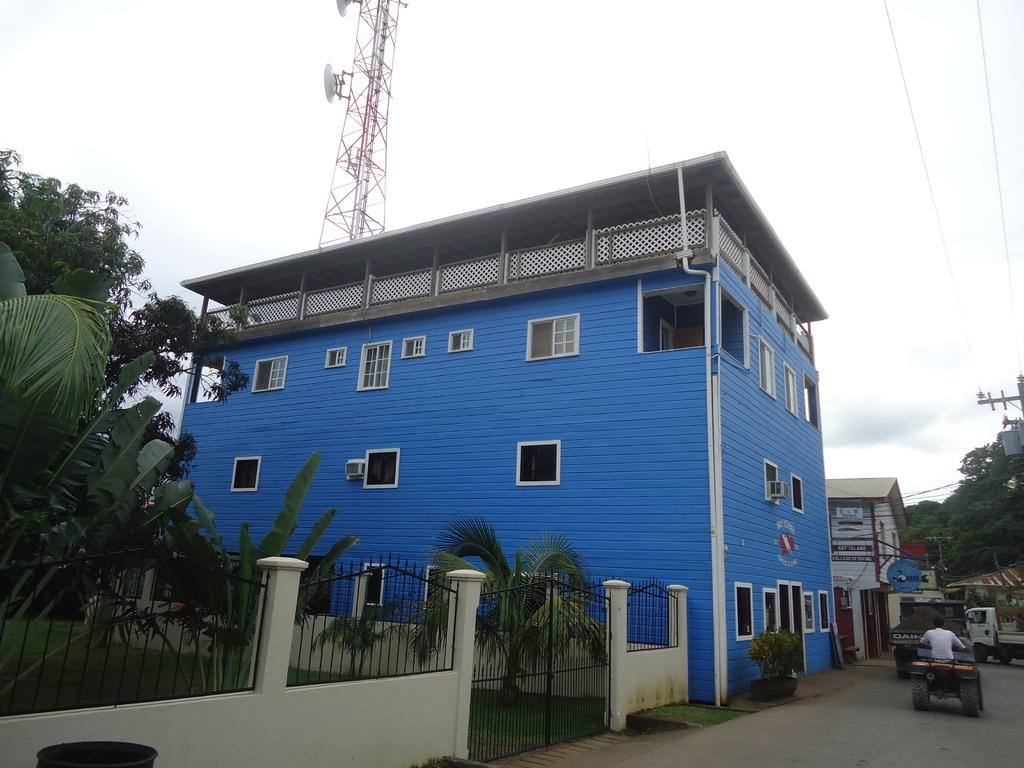What types of structures can be seen in the image? There are buildings in the image. What elements of nature are present in the image? There are plants, trees, and the sky visible in the image. What man-made objects can be seen in the image? There are vehicles, a grille, a gate, wires, windows, and a person in the image. Can you tell me how many ears are visible on the person in the image? There is no mention of ears in the image; only a person is mentioned. Where is the faucet located in the image? There is no faucet present in the image. 